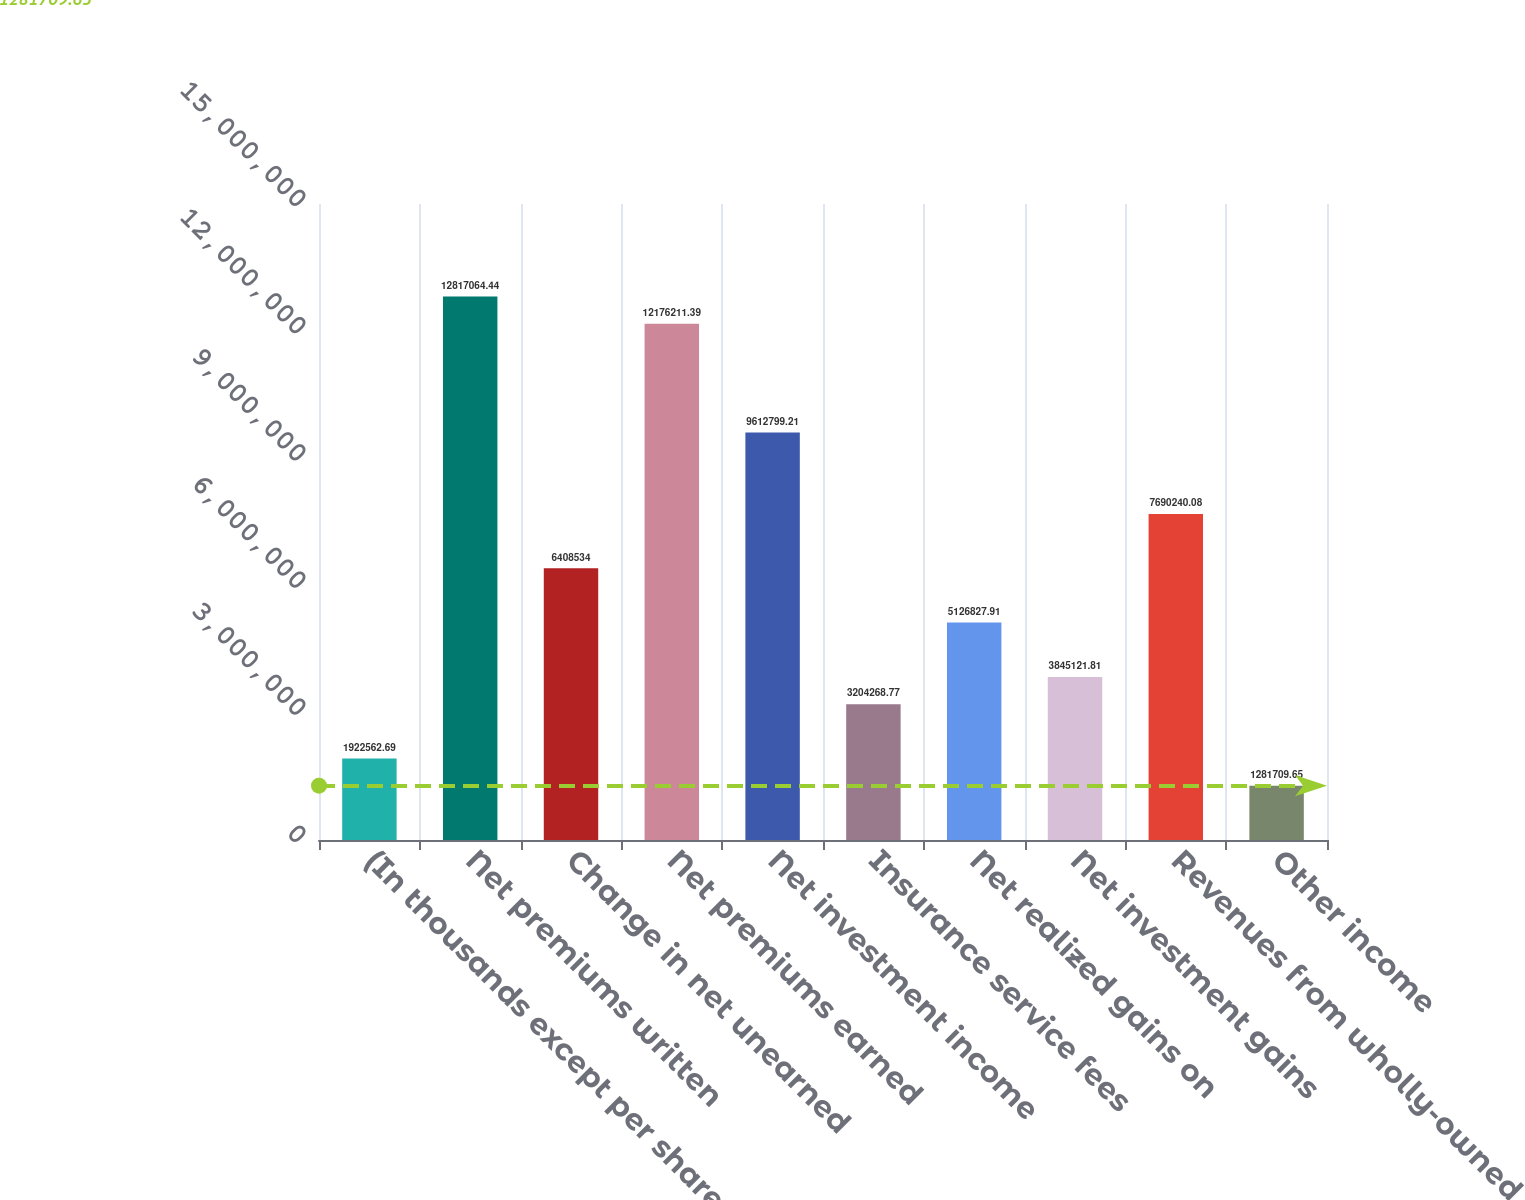Convert chart. <chart><loc_0><loc_0><loc_500><loc_500><bar_chart><fcel>(In thousands except per share<fcel>Net premiums written<fcel>Change in net unearned<fcel>Net premiums earned<fcel>Net investment income<fcel>Insurance service fees<fcel>Net realized gains on<fcel>Net investment gains<fcel>Revenues from wholly-owned<fcel>Other income<nl><fcel>1.92256e+06<fcel>1.28171e+07<fcel>6.40853e+06<fcel>1.21762e+07<fcel>9.6128e+06<fcel>3.20427e+06<fcel>5.12683e+06<fcel>3.84512e+06<fcel>7.69024e+06<fcel>1.28171e+06<nl></chart> 